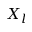Convert formula to latex. <formula><loc_0><loc_0><loc_500><loc_500>X _ { l }</formula> 